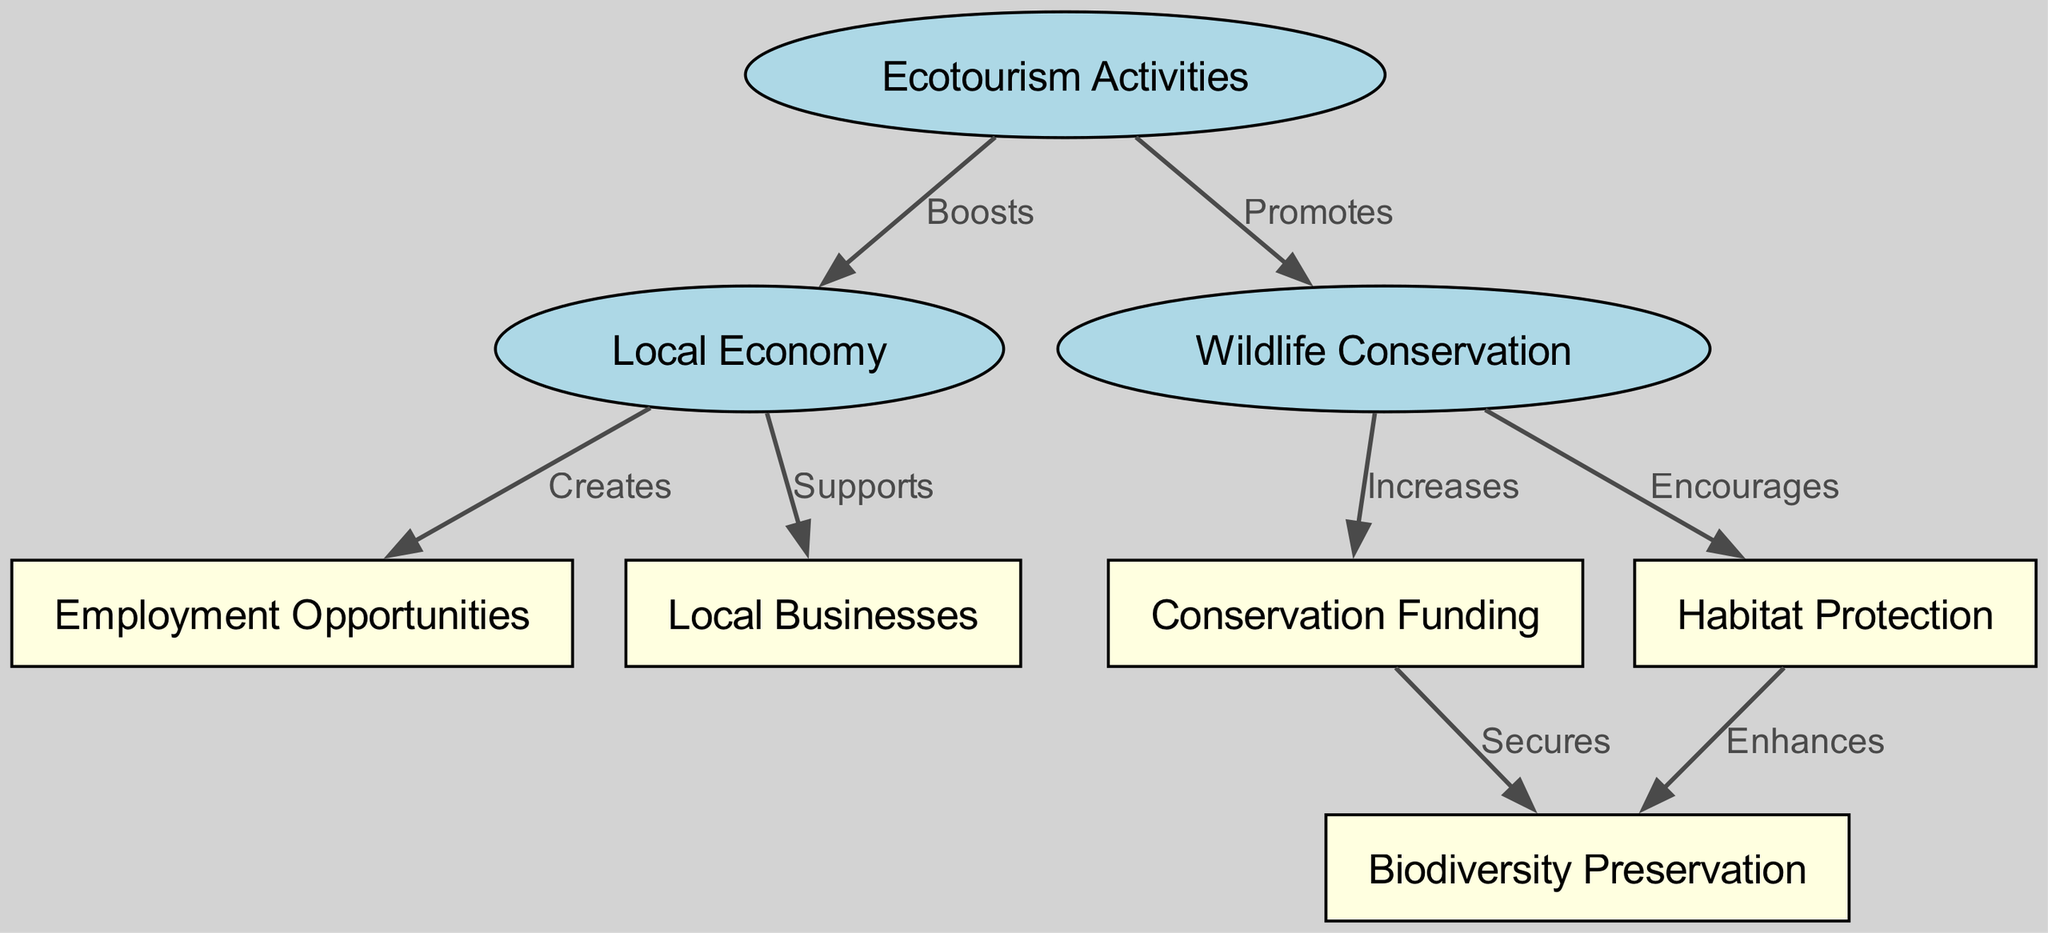What are the three main nodes in the diagram? The diagram contains three main nodes: Ecotourism Activities, Local Economy, and Wildlife Conservation, which can be observed as the central themes of the diagram.
Answer: Ecotourism Activities, Local Economy, Wildlife Conservation How many edges are present in the diagram? By counting the connections between nodes in the diagram, we observe that there are eight edges connecting the various nodes.
Answer: 8 What action does Ecotourism Activities perform on Local Economy? The diagram indicates that Ecotourism Activities "Boosts" the Local Economy, which shows a direct positive impact indicated by the specific labeled edge.
Answer: Boosts Which node is influenced by both Local Economy and Wildlife Conservation? The Local Economy influences Employment Opportunities, while Wildlife Conservation influences Conservation Funding, but the node that falls under the influence of both is not present. Instead, Wildlife Conservation and Local Economy link separately to their respective outputs. However, the impact on Employment Opportunities is through Local Economy.
Answer: Employment Opportunities What does Conservation Funding secure? Conservation Funding "Secures" Biodiversity Preservation as indicated by the flow of the diagram through the connections, which shows how funding leads directly to securing conservation efforts.
Answer: Biodiversity Preservation How does Wildlife Conservation impact Habitat Protection? Wildlife Conservation "Encourages" Habitat Protection according to the labeled edge in the diagram, indicating a supportive relationship between these two nodes.
Answer: Encourages What is created as a result of Local Economy? The Local Economy "Creates" Employment Opportunities, shown by the directed edge in the diagram linking the two nodes, highlighting the direct effect of economic growth.
Answer: Creates How does Habitat Protection relate to Biodiversity Preservation? The flow depicts that Habitat Protection "Enhances" Biodiversity Preservation, revealing how effective protection measures can contribute positively to the maintenance of biodiversity.
Answer: Enhances 